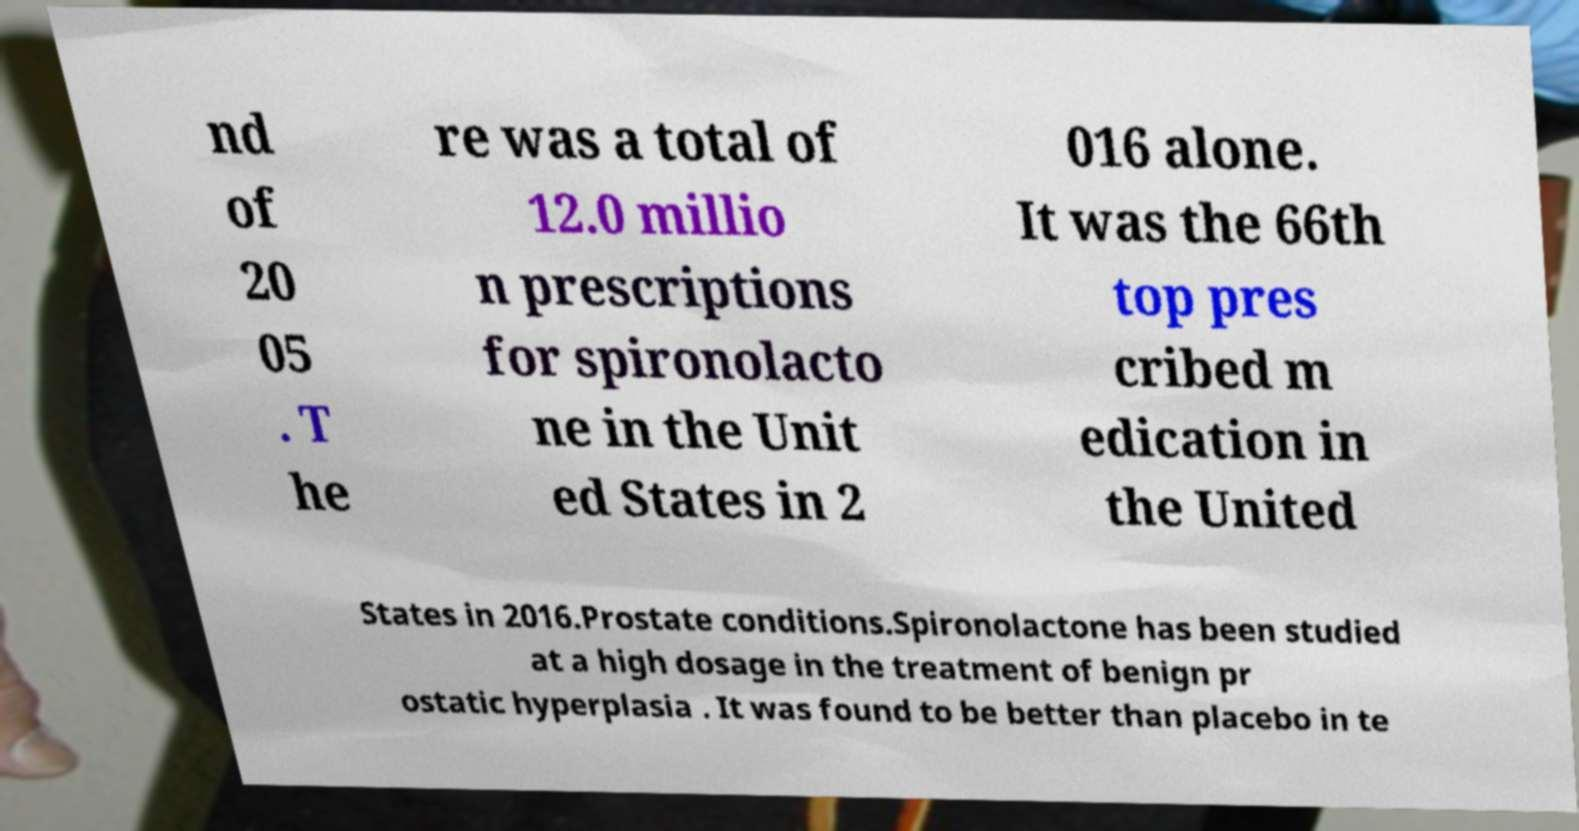Could you extract and type out the text from this image? nd of 20 05 . T he re was a total of 12.0 millio n prescriptions for spironolacto ne in the Unit ed States in 2 016 alone. It was the 66th top pres cribed m edication in the United States in 2016.Prostate conditions.Spironolactone has been studied at a high dosage in the treatment of benign pr ostatic hyperplasia . It was found to be better than placebo in te 